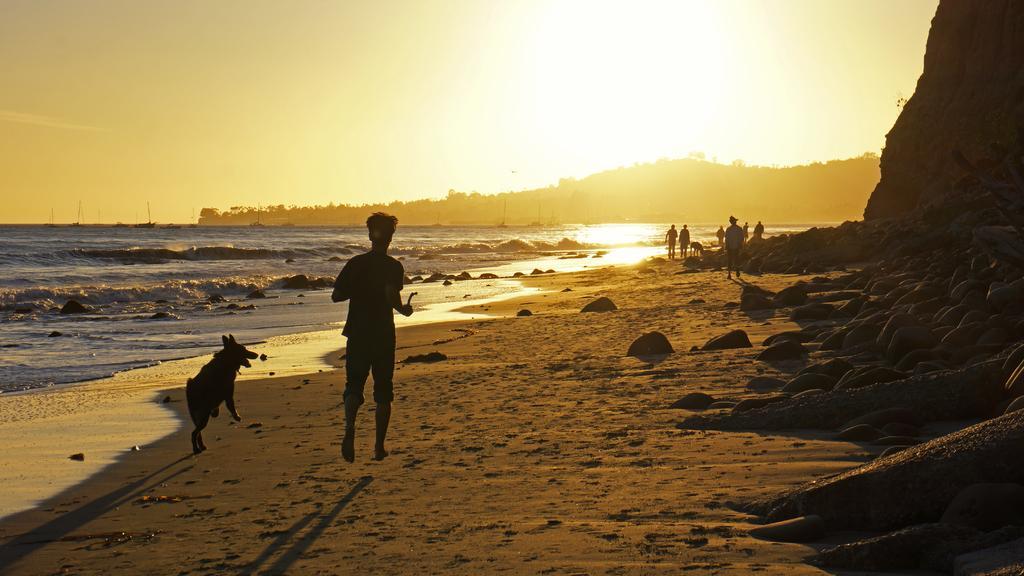Can you describe this image briefly? On the right side of the image there are some stones and hills. In the middle of the image few people are walking and running and there are some animals. At the bottom of the image there is sand. On the left side of the image there is water. At the top of the image there is sky and sun. 